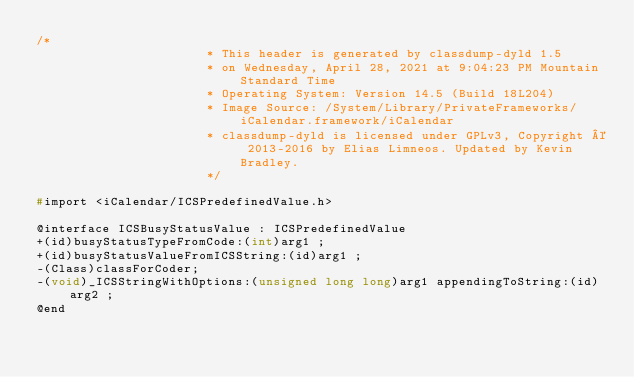Convert code to text. <code><loc_0><loc_0><loc_500><loc_500><_C_>/*
                       * This header is generated by classdump-dyld 1.5
                       * on Wednesday, April 28, 2021 at 9:04:23 PM Mountain Standard Time
                       * Operating System: Version 14.5 (Build 18L204)
                       * Image Source: /System/Library/PrivateFrameworks/iCalendar.framework/iCalendar
                       * classdump-dyld is licensed under GPLv3, Copyright © 2013-2016 by Elias Limneos. Updated by Kevin Bradley.
                       */

#import <iCalendar/ICSPredefinedValue.h>

@interface ICSBusyStatusValue : ICSPredefinedValue
+(id)busyStatusTypeFromCode:(int)arg1 ;
+(id)busyStatusValueFromICSString:(id)arg1 ;
-(Class)classForCoder;
-(void)_ICSStringWithOptions:(unsigned long long)arg1 appendingToString:(id)arg2 ;
@end

</code> 